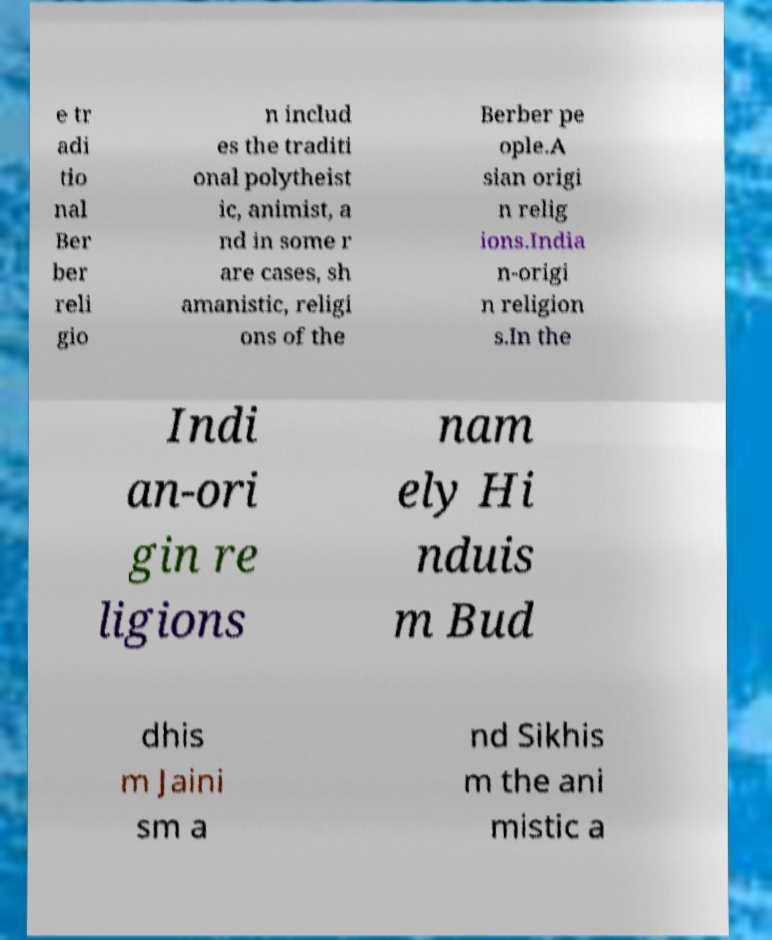Can you accurately transcribe the text from the provided image for me? e tr adi tio nal Ber ber reli gio n includ es the traditi onal polytheist ic, animist, a nd in some r are cases, sh amanistic, religi ons of the Berber pe ople.A sian origi n relig ions.India n-origi n religion s.In the Indi an-ori gin re ligions nam ely Hi nduis m Bud dhis m Jaini sm a nd Sikhis m the ani mistic a 